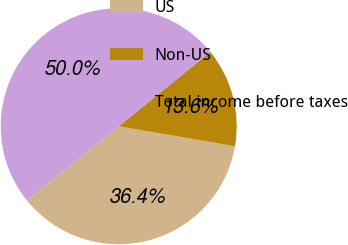<chart> <loc_0><loc_0><loc_500><loc_500><pie_chart><fcel>US<fcel>Non-US<fcel>Total income before taxes<nl><fcel>36.44%<fcel>13.56%<fcel>50.0%<nl></chart> 